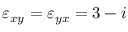<formula> <loc_0><loc_0><loc_500><loc_500>\varepsilon _ { x y } = \varepsilon _ { y x } = 3 - i</formula> 